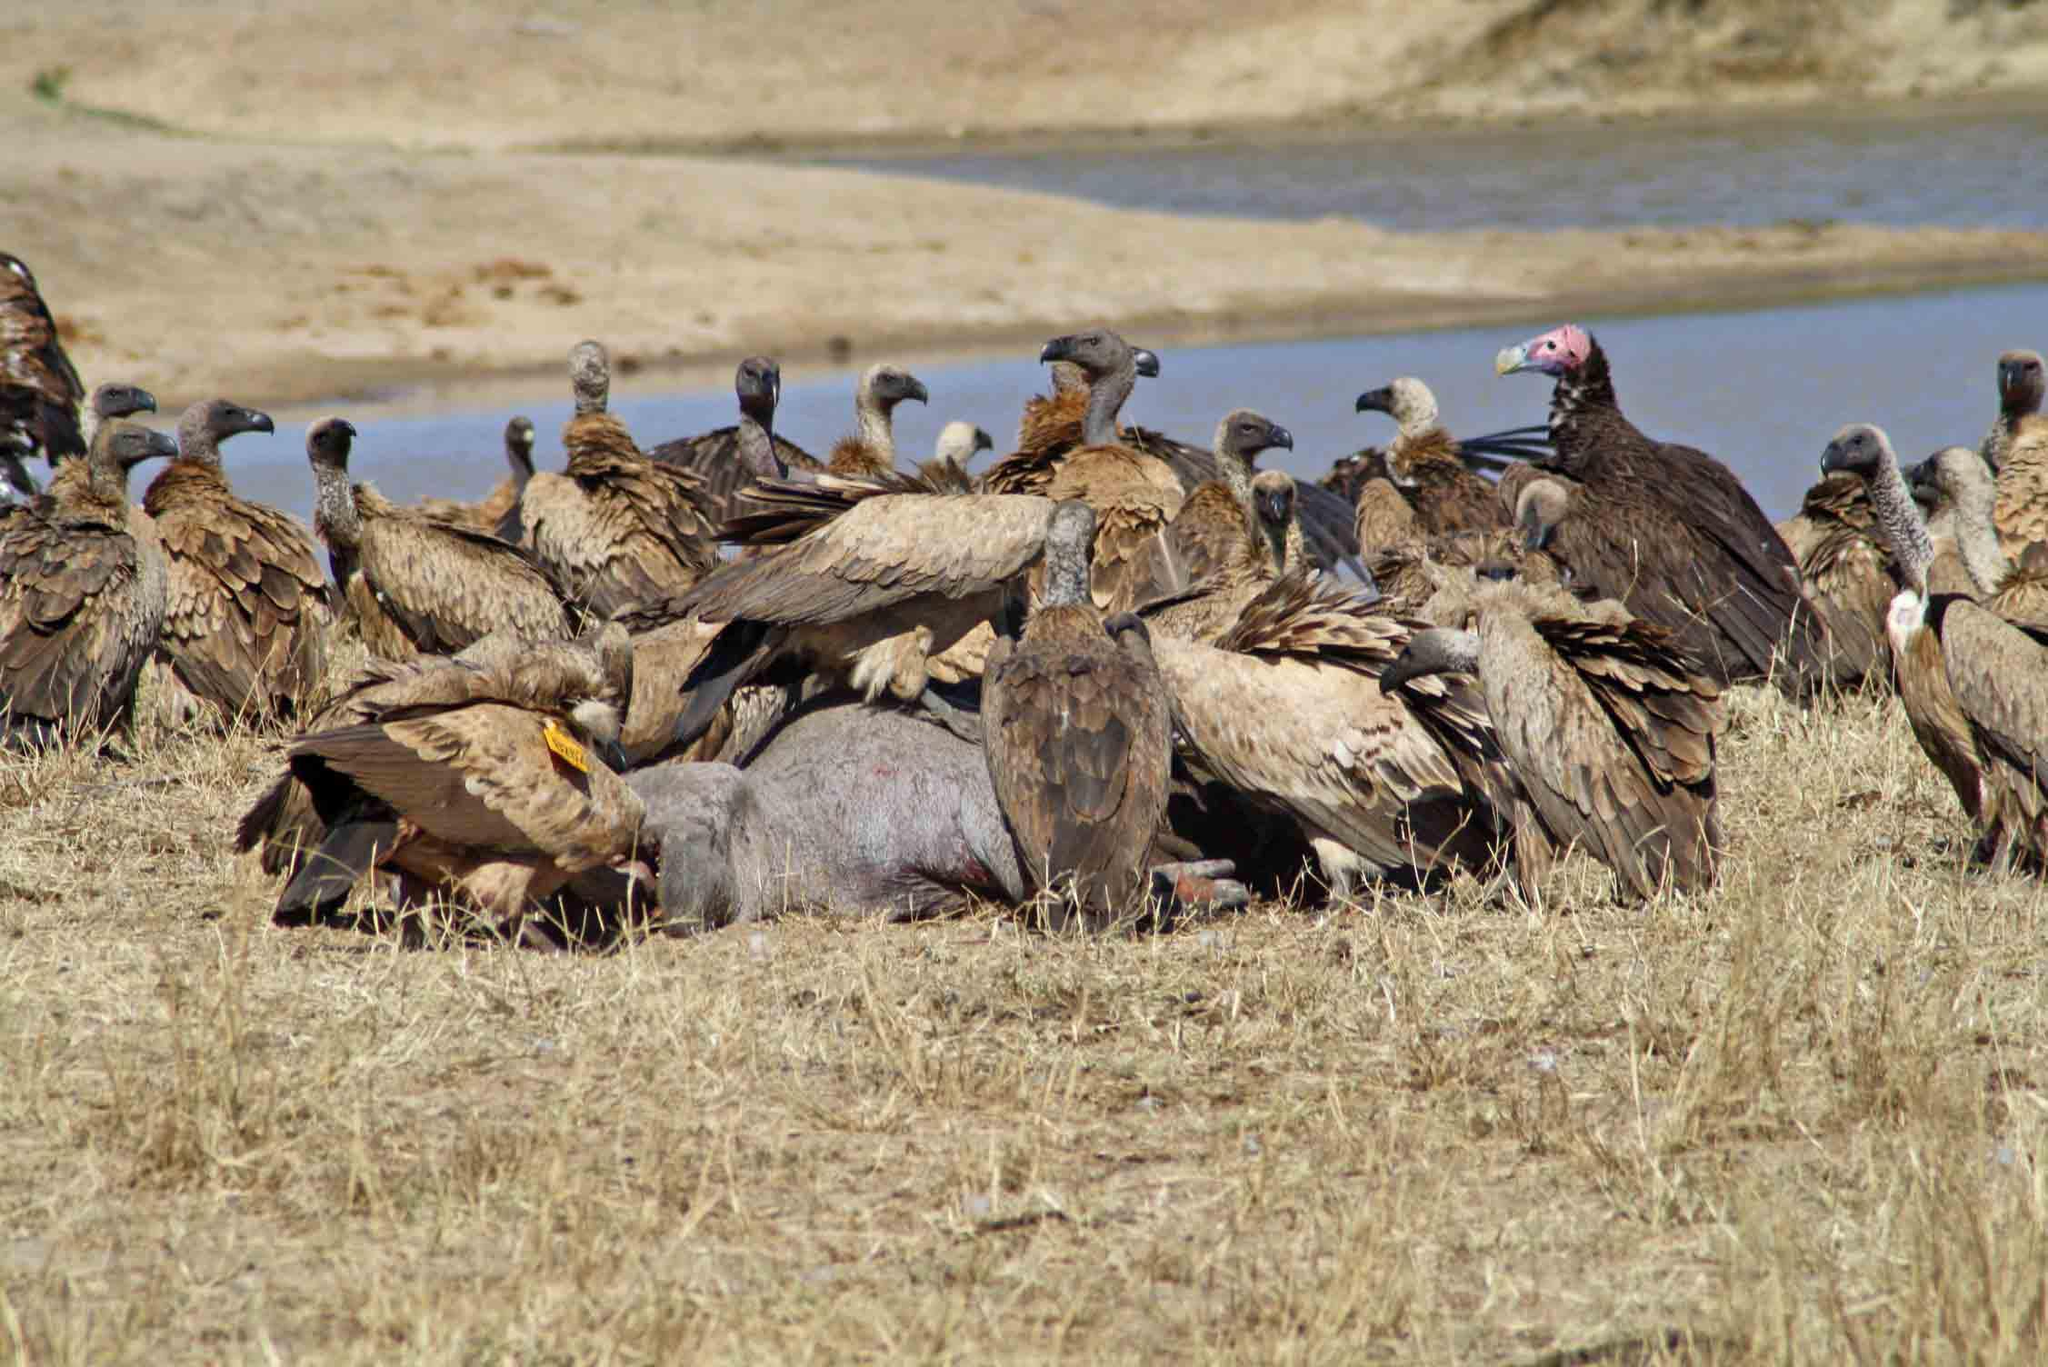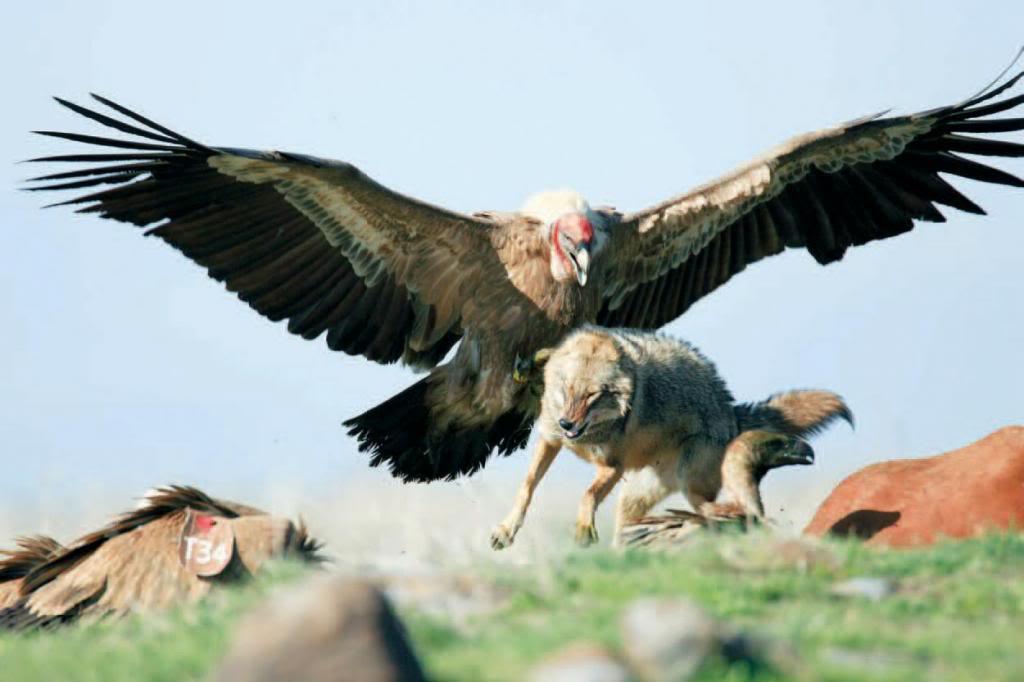The first image is the image on the left, the second image is the image on the right. Evaluate the accuracy of this statement regarding the images: "A single bird is landing with its wings spread in the image on the right.". Is it true? Answer yes or no. Yes. The first image is the image on the left, the second image is the image on the right. Considering the images on both sides, is "An image shows a group of vultures perched on something that is elevated." valid? Answer yes or no. No. 